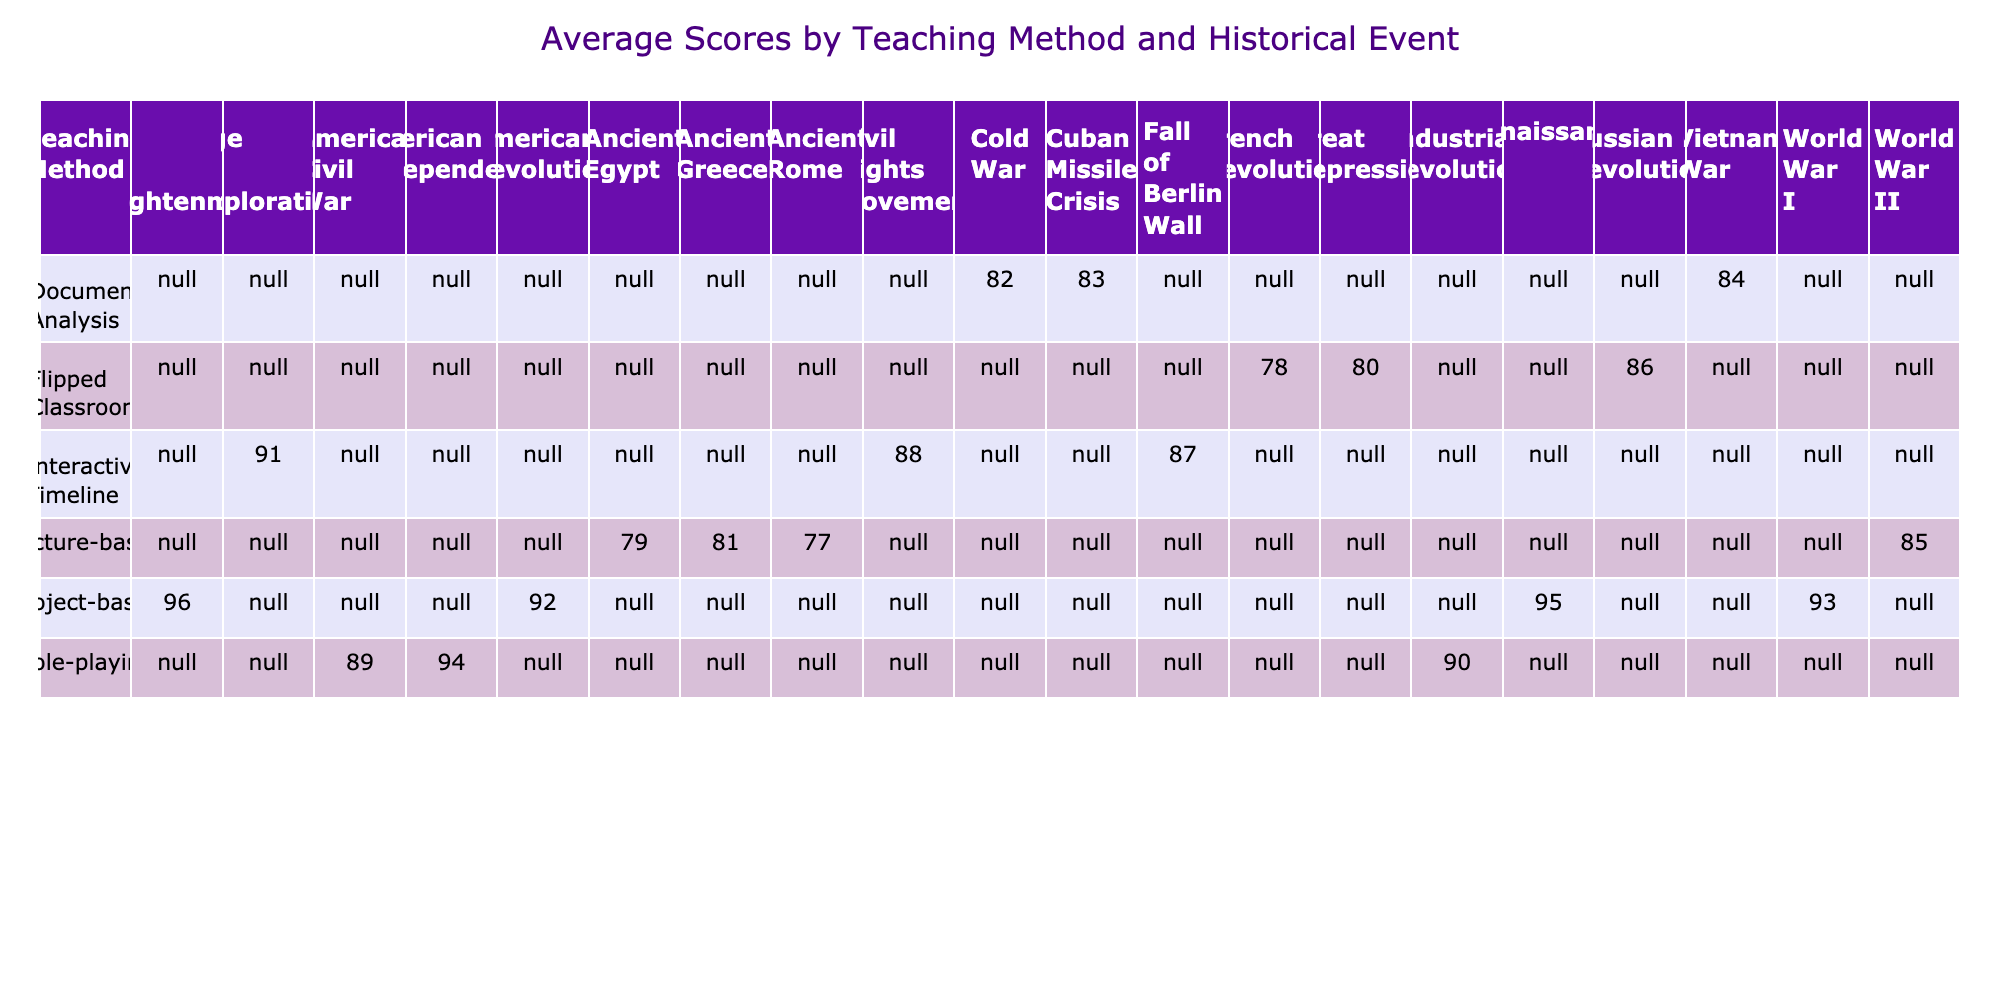What is the highest average score achieved using the Project-based teaching method? Looking at the table, the average score for the Project-based method can be found under that category. The scores for historical events taught with this method are 92, 95, 93, and 96. To find the average, we add these scores: 92 + 95 + 93 + 96 = 376. Dividing this total by 4 (the number of scores) gives us 376 / 4 = 94.
Answer: 94 Which historical event had the lowest average score in the Lecture-based teaching method? In the Lecture-based category, the historical events and their corresponding scores are World War II (85), Ancient Egypt (79), and Ancient Rome (77). Among these, the lowest score is 77 for the Ancient Rome event.
Answer: Ancient Rome Is the average score for the Flipped Classroom teaching method higher than that of the Interactive Timeline method? The average score for Flipped Classroom is calculated using the scores for French Revolution (78), Russian Revolution (86), and Great Depression (80), which sum to 244. Dividing by 3 gives an average of 244 / 3 ≈ 81.33. For the Interactive Timeline, the scores are 88, 91, and 87 totaling to 266, and averaging 266 / 3 ≈ 88.67. Comparing these averages, 81.33 is less than 88.67, indicating that Flipped Classroom is lower.
Answer: No How many teaching methods have an average score of 90 or above? By reviewing the scores from the table, the Teaching Methods with averages are Project-based (94), Role-playing (91), and Interactive Timeline (88.67). Adding up only those above 90 gives us three methods: Project-based, Role-playing, and Interactive Timeline.
Answer: 3 What is the average score for Document Analysis teaching method, and how does it compare to the average for Role-playing? The Document Analysis scores are Cold War (82), Vietnam War (84), and Cuban Missile Crisis (83). Adding these gives 82 + 84 + 83 = 249, dividing by 3 gives us an average of 249 / 3 = 83. The Role-playing events have scores of Industrial Revolution (90), American Civil War (89), and American Independence (94), summing to 273 and averaging 273 / 3 = 91. Comparing the two, 83 is lower than 91.
Answer: Document Analysis average is 83; Role-playing average is 91 Does the role-playing method result in consistently high scores for all historical events? The scores for the Role-playing method include Industrial Revolution (90), American Civil War (89), and American Independence (94). Although they are all high, there is variability, evidenced by the lowest score being 89. Therefore, this method does not yield consistent scores across all events.
Answer: No 